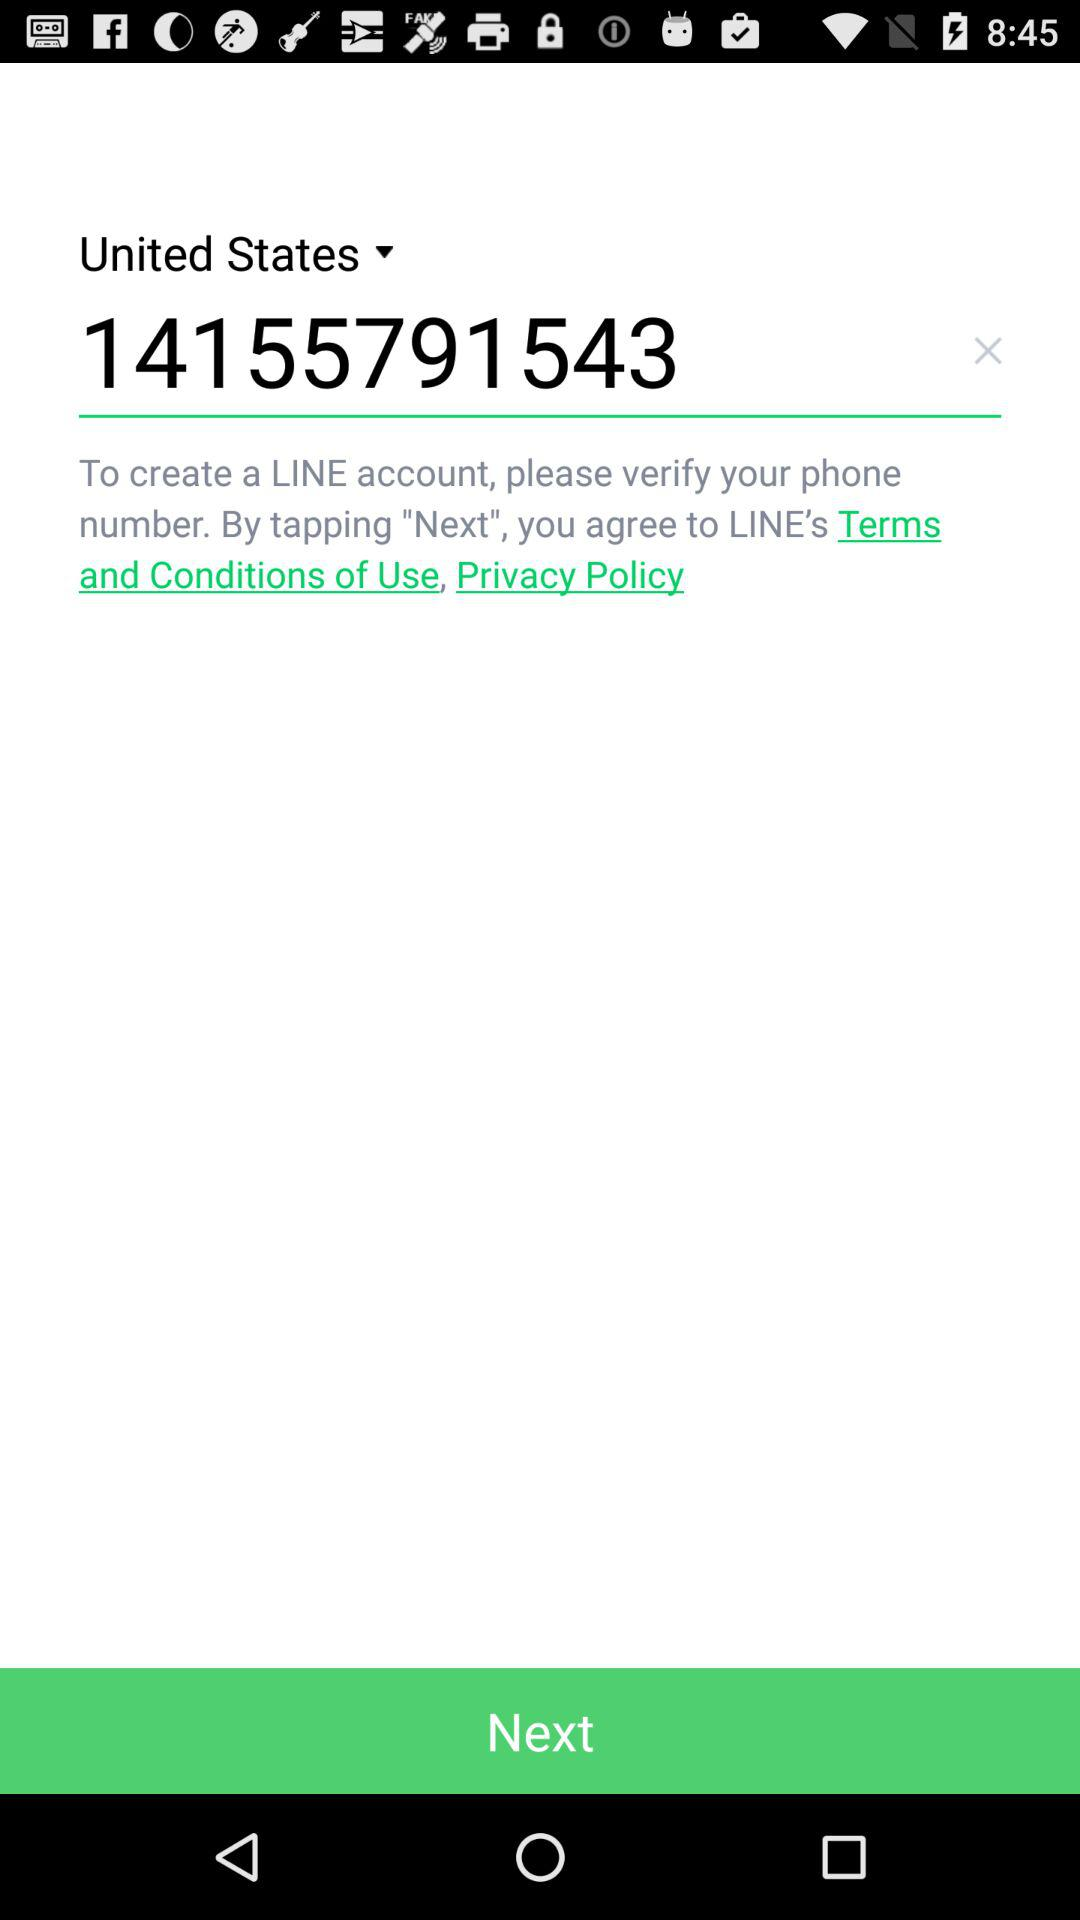What is the selected country? The selected country is the United States. 